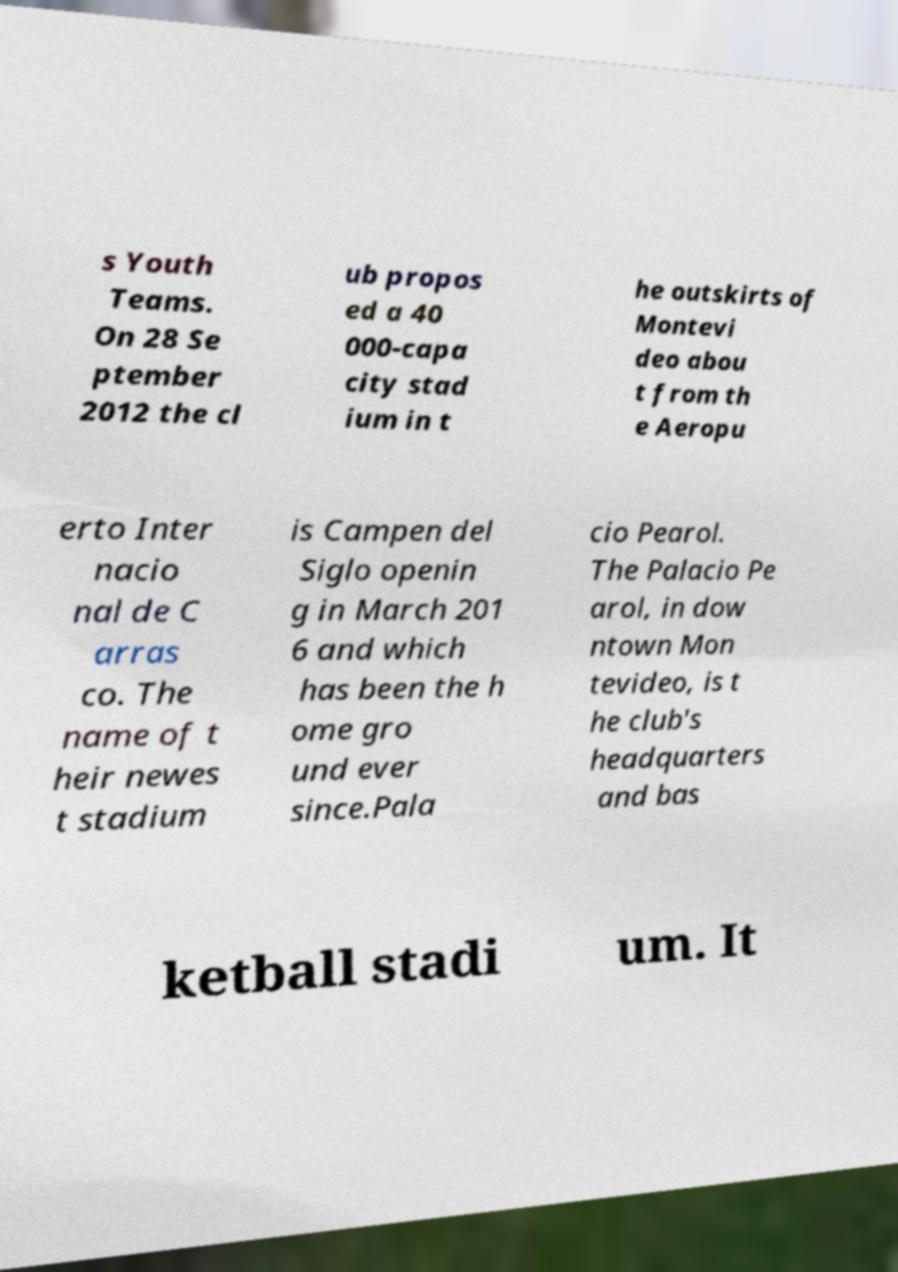What messages or text are displayed in this image? I need them in a readable, typed format. s Youth Teams. On 28 Se ptember 2012 the cl ub propos ed a 40 000-capa city stad ium in t he outskirts of Montevi deo abou t from th e Aeropu erto Inter nacio nal de C arras co. The name of t heir newes t stadium is Campen del Siglo openin g in March 201 6 and which has been the h ome gro und ever since.Pala cio Pearol. The Palacio Pe arol, in dow ntown Mon tevideo, is t he club's headquarters and bas ketball stadi um. It 